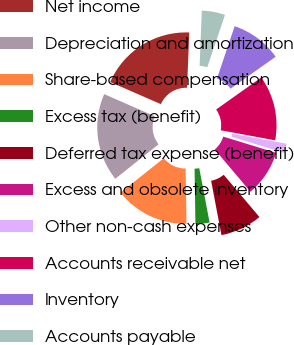Convert chart. <chart><loc_0><loc_0><loc_500><loc_500><pie_chart><fcel>Net income<fcel>Depreciation and amortization<fcel>Share-based compensation<fcel>Excess tax (benefit)<fcel>Deferred tax expense (benefit)<fcel>Excess and obsolete inventory<fcel>Other non-cash expenses<fcel>Accounts receivable net<fcel>Inventory<fcel>Accounts payable<nl><fcel>19.08%<fcel>17.26%<fcel>14.54%<fcel>2.74%<fcel>8.18%<fcel>9.09%<fcel>1.83%<fcel>12.72%<fcel>10.0%<fcel>4.55%<nl></chart> 